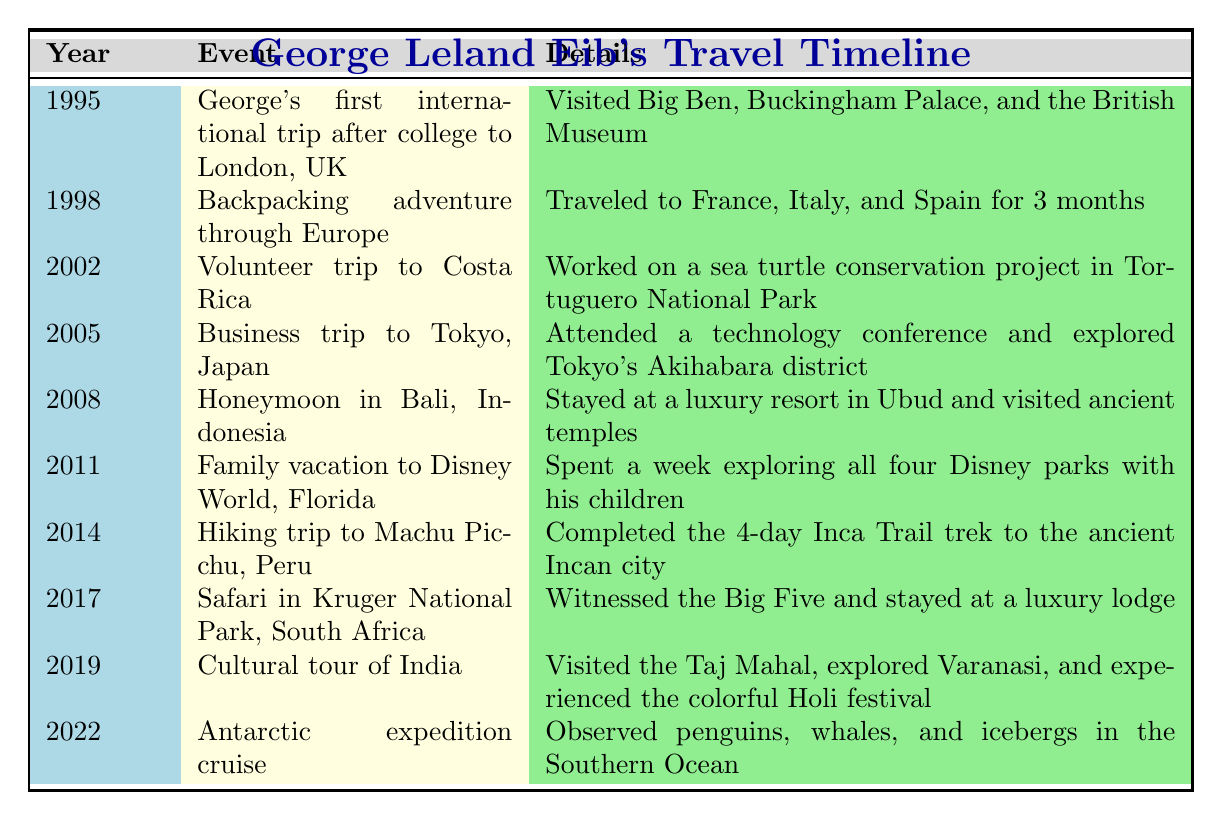What year did George have his first international trip? According to the table, George's first international trip occurred in 1995, as noted in the first row under the year column.
Answer: 1995 How many years passed between the trip to Costa Rica and the trip to Machu Picchu? The trip to Costa Rica was in 2002 and the trip to Machu Picchu was in 2014. The difference is 2014 - 2002 = 12 years.
Answer: 12 years Did George ever travel to South America, and if so, which trip was it? Yes, George traveled to South America during his hiking trip to Machu Picchu in 2014, as stated in the corresponding row.
Answer: Yes, the hiking trip to Machu Picchu in 2014 What destination did George visit during his honeymoon? The table indicates that George's honeymoon was in Bali, Indonesia, as listed in the row for 2008.
Answer: Bali, Indonesia How many trips did George take to Asia? Referring to the table, the trips to Asia are in 2005 (Tokyo, Japan), 2008 (Bali, Indonesia), and 2019 (Cultural tour of India). This totals 3 trips.
Answer: 3 trips In which year did George visit the Taj Mahal? The table shows that George visited the Taj Mahal in 2019, specifically during his cultural tour of India.
Answer: 2019 What is the average year of the trips listed in the table? To find the average year, we add all the years (1995 + 1998 + 2002 + 2005 + 2008 + 2011 + 2014 + 2017 + 2019 + 2022 = 2011) and then divide by the number of trips (10). Thus, the average is 2011/10 = 2011.
Answer: 2011 Was there a trip centered around wildlife, and if so, what was it? Yes, in 2017, George went on a safari in Kruger National Park, South Africa, where he witnessed the Big Five, as noted in the table.
Answer: Yes, the safari in Kruger National Park in 2017 What notable events did George include in his backpacking adventure? The table states that during the backpacking trip in 1998, George traveled to France, Italy, and Spain for 3 months, indicating no specific notable events are listed.
Answer: No specific events listed 